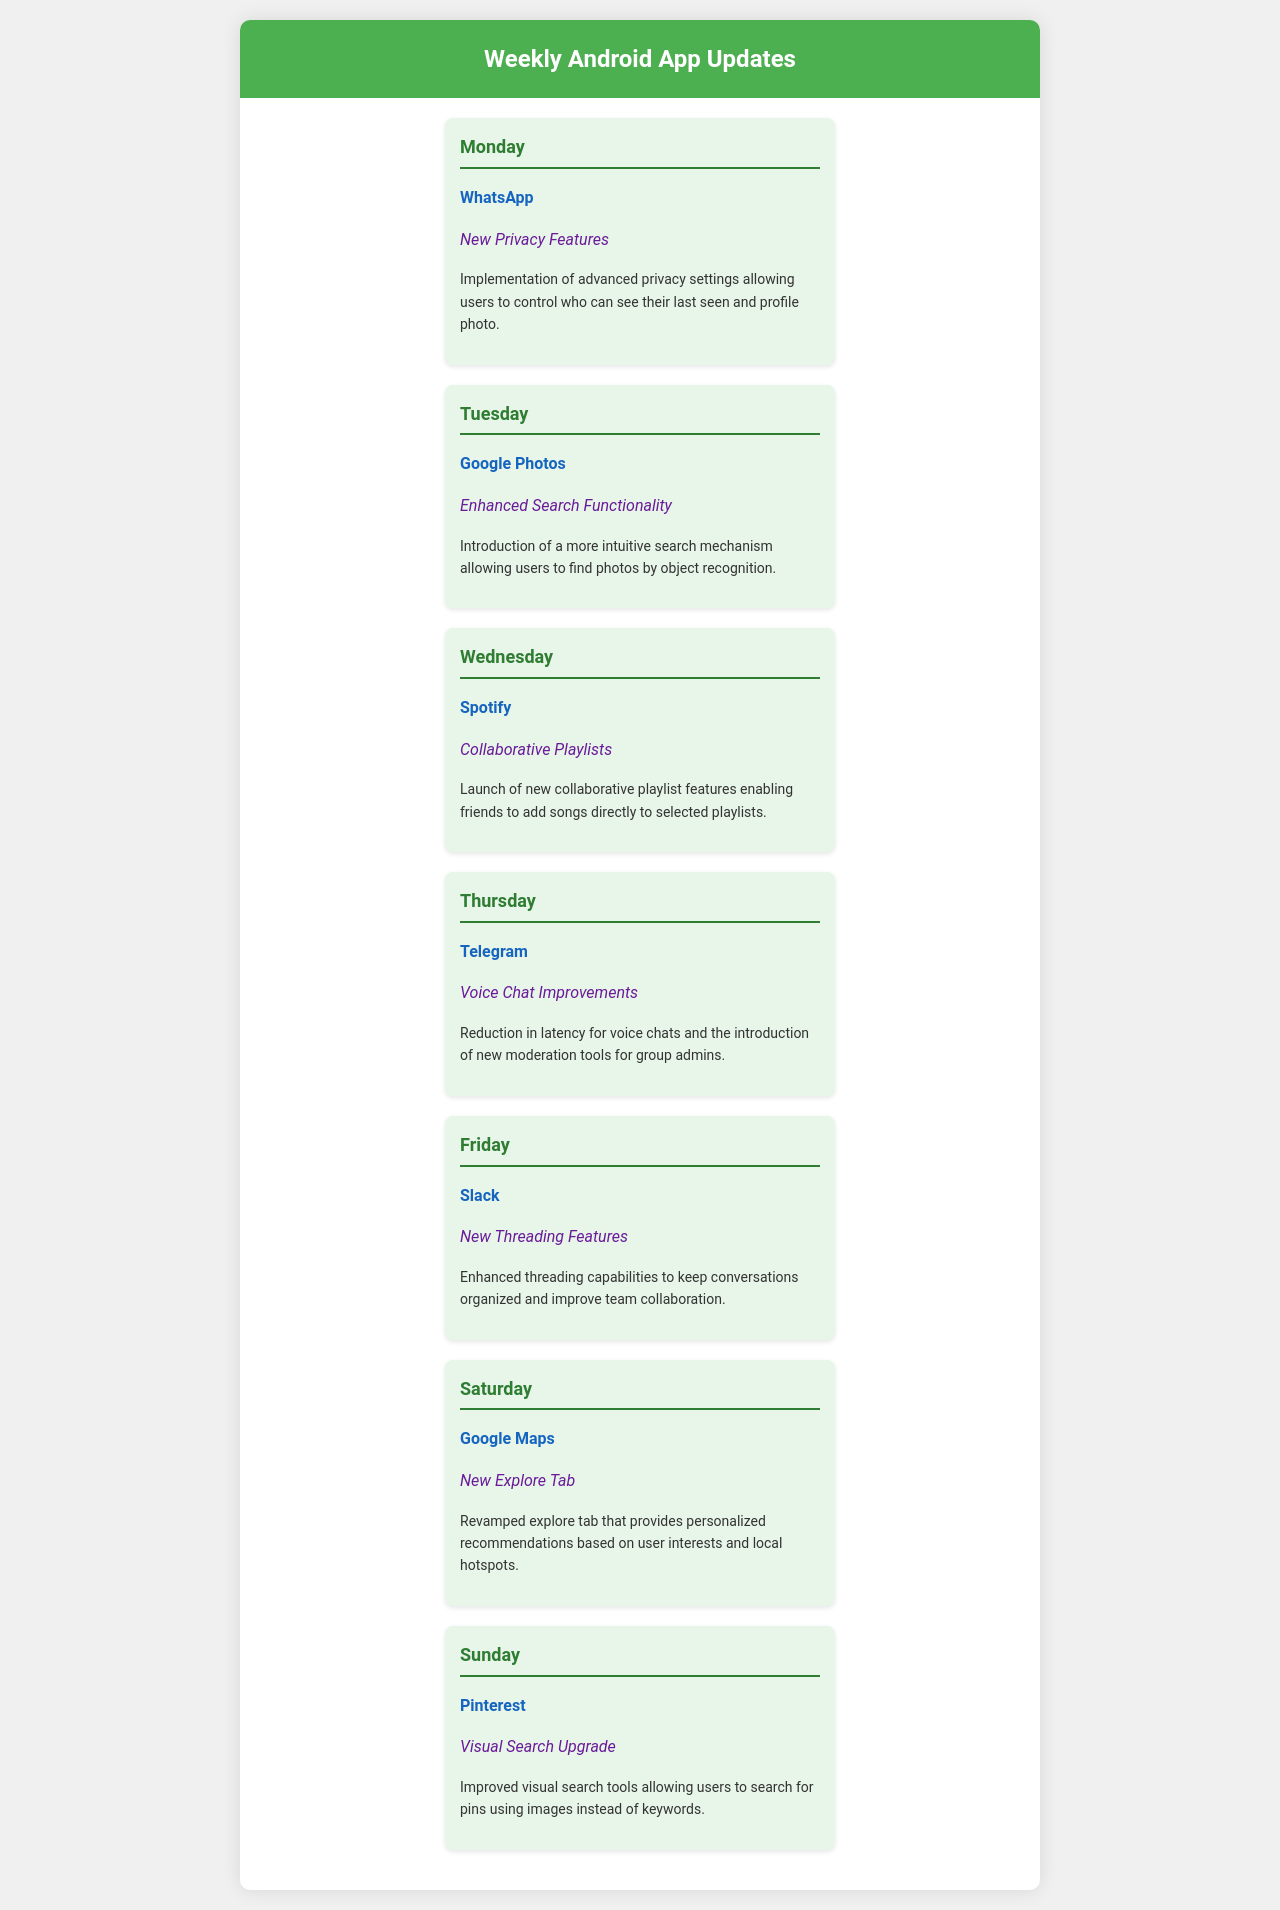What is the new feature for WhatsApp? The document states that WhatsApp has implemented new privacy features allowing users to control who can see their last seen and profile photo.
Answer: New Privacy Features What app received enhanced search functionality on Tuesday? According to the schedule, Google Photos was updated with enhanced search functionality that allows users to find photos by object recognition.
Answer: Google Photos What new feature was introduced for Spotify? The document mentions that Spotify launched collaborative playlist features enabling friends to add songs directly to selected playlists.
Answer: Collaborative Playlists Which day is dedicated to Telegram? The schedule shows Thursday is dedicated to Telegram, which received voice chat improvements.
Answer: Thursday What improvement does Google Maps showcase? The document highlights that Google Maps introduced a new explore tab that offers personalized recommendations based on user interests.
Answer: New Explore Tab What type of features were enhanced for Slack? According to the schedule, Slack enhanced its threading capabilities to keep conversations organized.
Answer: New Threading Features On which day does the visual search upgrade for Pinterest occur? The document indicates that the visual search upgrade for Pinterest is featured on Sunday.
Answer: Sunday How many apps received updates on the weekend? The schedule shows that two apps, Google Maps and Pinterest, received updates over the weekend.
Answer: Two 